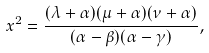<formula> <loc_0><loc_0><loc_500><loc_500>x ^ { 2 } = \frac { ( \lambda + \alpha ) ( \mu + \alpha ) ( \nu + \alpha ) } { ( \alpha - \beta ) ( \alpha - \gamma ) } ,</formula> 